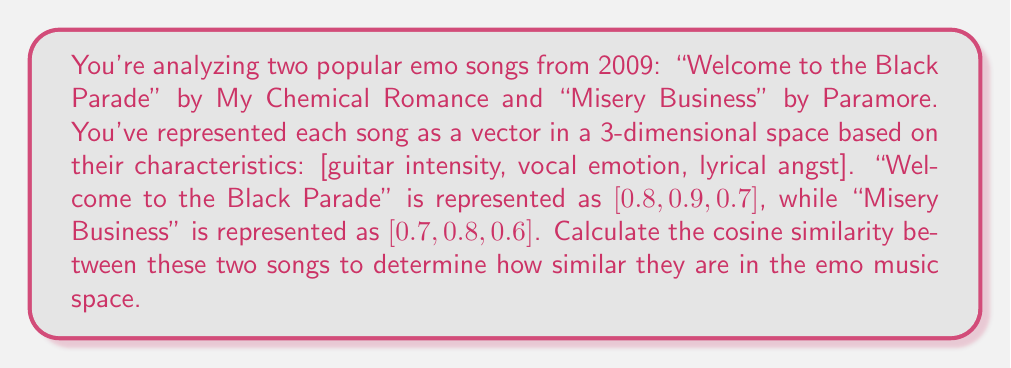Provide a solution to this math problem. To solve this problem, we'll use the cosine similarity formula:

$$\text{cosine similarity} = \frac{\mathbf{A} \cdot \mathbf{B}}{\|\mathbf{A}\| \|\mathbf{B}\|}$$

Where $\mathbf{A}$ and $\mathbf{B}$ are the vectors representing the two songs, $\cdot$ denotes the dot product, and $\|\mathbf{A}\|$ and $\|\mathbf{B}\|$ are the magnitudes of the vectors.

Let $\mathbf{A} = [0.8, 0.9, 0.7]$ (Welcome to the Black Parade)
Let $\mathbf{B} = [0.7, 0.8, 0.6]$ (Misery Business)

Step 1: Calculate the dot product $\mathbf{A} \cdot \mathbf{B}$
$\mathbf{A} \cdot \mathbf{B} = (0.8 \times 0.7) + (0.9 \times 0.8) + (0.7 \times 0.6) = 0.56 + 0.72 + 0.42 = 1.70$

Step 2: Calculate the magnitudes $\|\mathbf{A}\|$ and $\|\mathbf{B}\|$
$\|\mathbf{A}\| = \sqrt{0.8^2 + 0.9^2 + 0.7^2} = \sqrt{0.64 + 0.81 + 0.49} = \sqrt{1.94} \approx 1.3928$
$\|\mathbf{B}\| = \sqrt{0.7^2 + 0.8^2 + 0.6^2} = \sqrt{0.49 + 0.64 + 0.36} = \sqrt{1.49} \approx 1.2207$

Step 3: Apply the cosine similarity formula
$$\text{cosine similarity} = \frac{1.70}{1.3928 \times 1.2207} \approx 0.9986$$
Answer: The cosine similarity between "Welcome to the Black Parade" and "Misery Business" is approximately 0.9986, indicating a very high similarity in their emo characteristics within the given vector space model. 